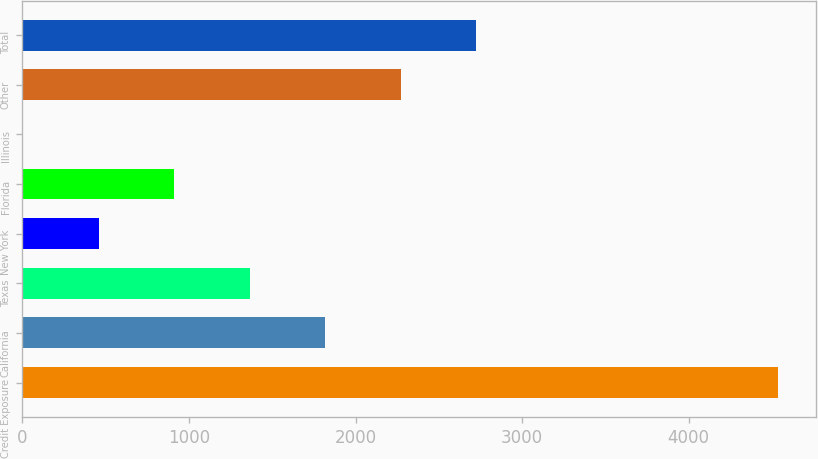<chart> <loc_0><loc_0><loc_500><loc_500><bar_chart><fcel>Credit Exposure<fcel>California<fcel>Texas<fcel>New York<fcel>Florida<fcel>Illinois<fcel>Other<fcel>Total<nl><fcel>4536<fcel>1816.8<fcel>1363.6<fcel>457.2<fcel>910.4<fcel>4<fcel>2270<fcel>2723.2<nl></chart> 